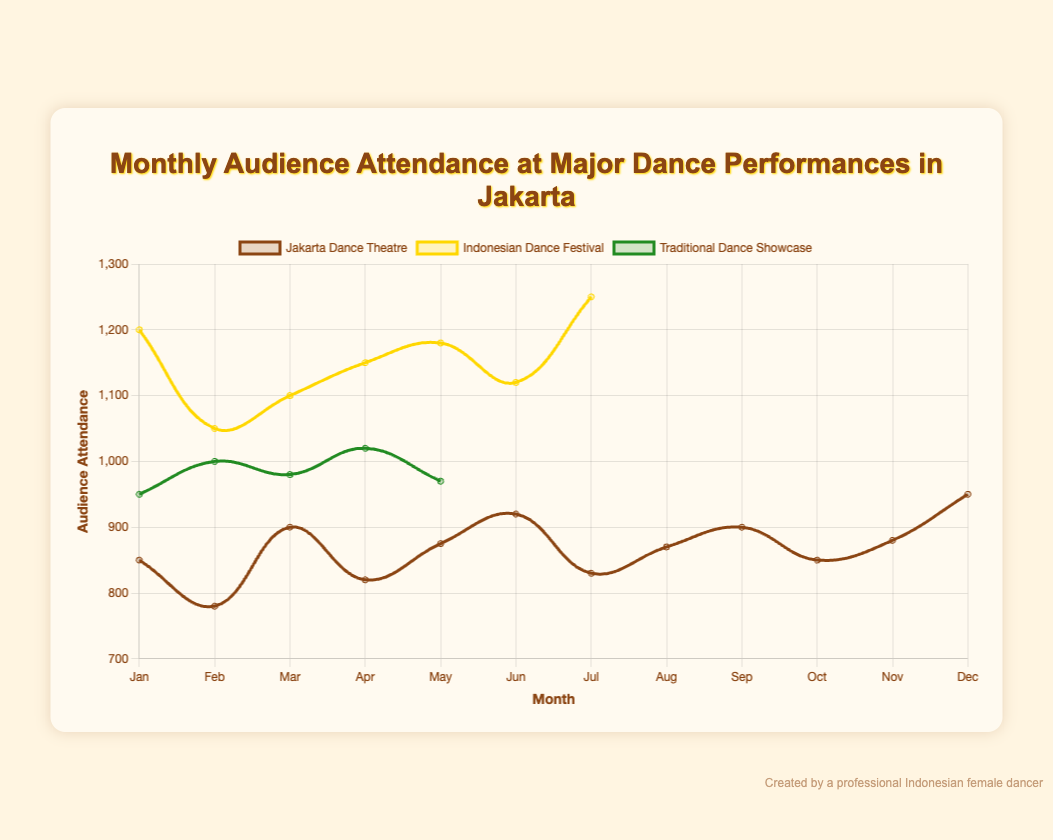What is the total audience attendance for the Indonesian Dance Festival in the first quarter of the year? The first quarter includes January, February, and March. The audience attendance in these months is 1200 + 1050 + 1100 = 3350.
Answer: 3350 Which performance had the highest audience attendance in December? In December, the Jakarta Dance Theatre had 950 attendees, while the Indonesian Dance Festival had 1250.
Answer: Indonesian Dance Festival Compare the audience attendance of Traditional Dance Showcase in March and May. Which month had higher attendance? In March, the Traditional Dance Showcase had 950 attendees. In May, it had 1000 attendees.
Answer: May Among Jakarta Dance Theatre and Indonesian Dance Festival, which one had the more significant increase in audience attendance from February to March? Jakarta Dance Theatre increased from 780 to 900, a difference of 120. Indonesian Dance Festival increased from 1050 to 1100, a difference of 50.
Answer: Jakarta Dance Theatre Was there any month where the audience attendance was the same for Jakarta Dance Theatre and Indonesian Dance Festival? By examining the figure, there is no month where Jakarta Dance Theatre and Indonesian Dance Festival had the same audience attendance.
Answer: No In which month did the Jakarta Dance Theatre have its lowest attendance? By looking at the trend for Jakarta Dance Theatre, the lowest attendance was in February with 780 attendees.
Answer: February What is the average monthly audience attendance for Traditional Dance Showcase over the year? The attendance values are 950 (March), 1000 (May), 980 (July), 1020 (September), 970 (November). The average is (950 + 1000 + 980 + 1020 + 970) / 5 = 984.
Answer: 984 Compare the attendance trend of Jakarta Dance Theatre and Traditional Dance Showcase. Which one had a more consistent attendance level throughout the year? Jakarta Dance Theatre shows more fluctuation throughout the year, while Traditional Dance Showcase has fewer data points but looks relatively steady.
Answer: Traditional Dance Showcase What is the difference in attendance between Jakarta Dance Theatre and Indonesian Dance Festival in June? In June, Jakarta Dance Theatre had 920 attendees, and Indonesian Dance Festival had 1150. The difference is 1150 - 920 = 230.
Answer: 230 Which performance had the highest average monthly audience attendance throughout the year? To determine the highest average, calculate the average for each performance. Indonesian Dance Festival has the consistently highest monthly attendance, making it likely the highest on average.
Answer: Indonesian Dance Festival 